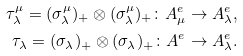<formula> <loc_0><loc_0><loc_500><loc_500>\tau ^ { \mu } _ { \lambda } = ( \sigma ^ { \mu } _ { \lambda } ) _ { + } \otimes ( \sigma ^ { \mu } _ { \lambda } ) _ { + } \colon A _ { \mu } ^ { e } \to A _ { \lambda } ^ { e } , \\ \tau _ { \lambda } = ( \sigma _ { \lambda } ) _ { + } \otimes ( \sigma _ { \lambda } ) _ { + } \colon A ^ { e } \to A _ { \lambda } ^ { e } .</formula> 